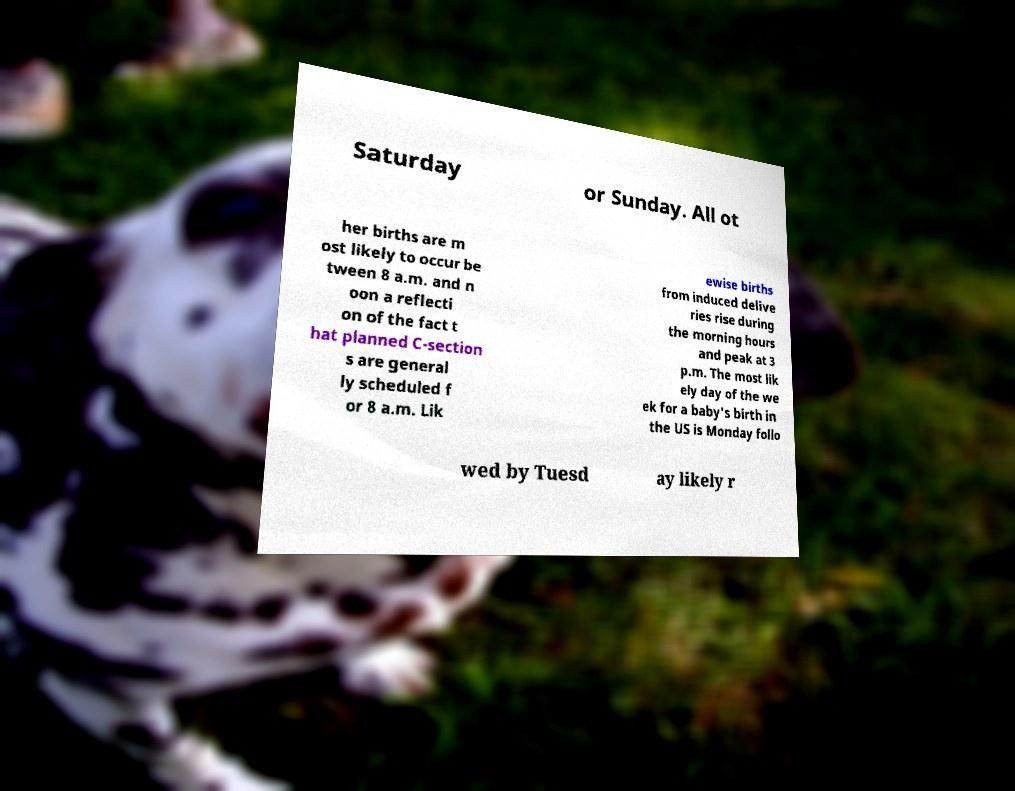What messages or text are displayed in this image? I need them in a readable, typed format. Saturday or Sunday. All ot her births are m ost likely to occur be tween 8 a.m. and n oon a reflecti on of the fact t hat planned C-section s are general ly scheduled f or 8 a.m. Lik ewise births from induced delive ries rise during the morning hours and peak at 3 p.m. The most lik ely day of the we ek for a baby's birth in the US is Monday follo wed by Tuesd ay likely r 